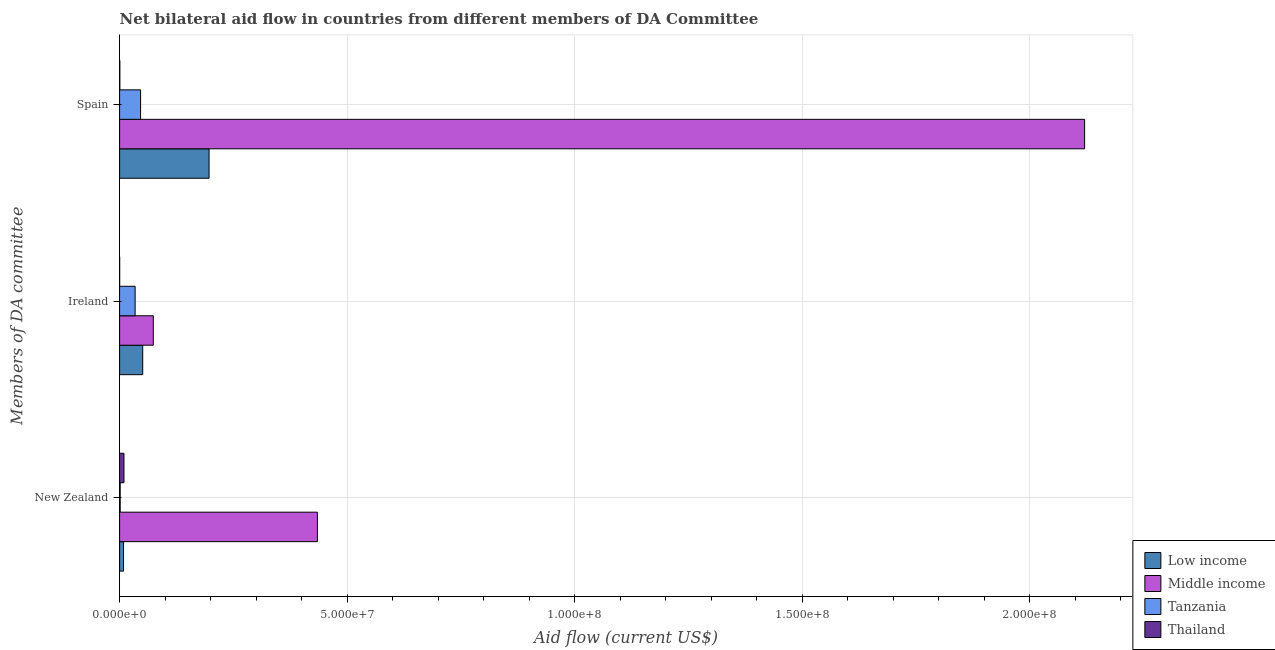How many different coloured bars are there?
Make the answer very short. 4. Are the number of bars per tick equal to the number of legend labels?
Your response must be concise. Yes. Are the number of bars on each tick of the Y-axis equal?
Your answer should be compact. Yes. How many bars are there on the 1st tick from the bottom?
Your response must be concise. 4. What is the label of the 2nd group of bars from the top?
Your response must be concise. Ireland. What is the amount of aid provided by spain in Low income?
Offer a terse response. 1.97e+07. Across all countries, what is the maximum amount of aid provided by ireland?
Keep it short and to the point. 7.41e+06. Across all countries, what is the minimum amount of aid provided by new zealand?
Keep it short and to the point. 1.30e+05. In which country was the amount of aid provided by new zealand minimum?
Keep it short and to the point. Tanzania. What is the total amount of aid provided by ireland in the graph?
Make the answer very short. 1.59e+07. What is the difference between the amount of aid provided by spain in Tanzania and that in Low income?
Offer a terse response. -1.50e+07. What is the difference between the amount of aid provided by ireland in Middle income and the amount of aid provided by new zealand in Tanzania?
Keep it short and to the point. 7.28e+06. What is the average amount of aid provided by new zealand per country?
Provide a short and direct response. 1.14e+07. What is the difference between the amount of aid provided by ireland and amount of aid provided by spain in Low income?
Provide a short and direct response. -1.46e+07. What is the ratio of the amount of aid provided by new zealand in Thailand to that in Tanzania?
Make the answer very short. 7.38. Is the amount of aid provided by new zealand in Low income less than that in Thailand?
Give a very brief answer. Yes. What is the difference between the highest and the second highest amount of aid provided by spain?
Ensure brevity in your answer.  1.92e+08. What is the difference between the highest and the lowest amount of aid provided by spain?
Provide a short and direct response. 2.12e+08. In how many countries, is the amount of aid provided by new zealand greater than the average amount of aid provided by new zealand taken over all countries?
Provide a short and direct response. 1. What does the 1st bar from the top in Spain represents?
Provide a short and direct response. Thailand. What does the 1st bar from the bottom in Ireland represents?
Offer a terse response. Low income. Is it the case that in every country, the sum of the amount of aid provided by new zealand and amount of aid provided by ireland is greater than the amount of aid provided by spain?
Provide a succinct answer. No. How many bars are there?
Keep it short and to the point. 12. Are all the bars in the graph horizontal?
Your answer should be compact. Yes. What is the difference between two consecutive major ticks on the X-axis?
Offer a very short reply. 5.00e+07. Are the values on the major ticks of X-axis written in scientific E-notation?
Your response must be concise. Yes. Does the graph contain grids?
Keep it short and to the point. Yes. Where does the legend appear in the graph?
Make the answer very short. Bottom right. How are the legend labels stacked?
Your response must be concise. Vertical. What is the title of the graph?
Offer a terse response. Net bilateral aid flow in countries from different members of DA Committee. Does "Europe(all income levels)" appear as one of the legend labels in the graph?
Provide a short and direct response. No. What is the label or title of the X-axis?
Provide a succinct answer. Aid flow (current US$). What is the label or title of the Y-axis?
Provide a succinct answer. Members of DA committee. What is the Aid flow (current US$) of Low income in New Zealand?
Your answer should be very brief. 8.70e+05. What is the Aid flow (current US$) in Middle income in New Zealand?
Make the answer very short. 4.35e+07. What is the Aid flow (current US$) of Tanzania in New Zealand?
Offer a very short reply. 1.30e+05. What is the Aid flow (current US$) in Thailand in New Zealand?
Your answer should be compact. 9.60e+05. What is the Aid flow (current US$) in Low income in Ireland?
Provide a short and direct response. 5.08e+06. What is the Aid flow (current US$) of Middle income in Ireland?
Your answer should be very brief. 7.41e+06. What is the Aid flow (current US$) of Tanzania in Ireland?
Keep it short and to the point. 3.41e+06. What is the Aid flow (current US$) of Low income in Spain?
Give a very brief answer. 1.97e+07. What is the Aid flow (current US$) of Middle income in Spain?
Offer a very short reply. 2.12e+08. What is the Aid flow (current US$) in Tanzania in Spain?
Your response must be concise. 4.61e+06. What is the Aid flow (current US$) in Thailand in Spain?
Provide a short and direct response. 5.00e+04. Across all Members of DA committee, what is the maximum Aid flow (current US$) in Low income?
Ensure brevity in your answer.  1.97e+07. Across all Members of DA committee, what is the maximum Aid flow (current US$) of Middle income?
Your answer should be very brief. 2.12e+08. Across all Members of DA committee, what is the maximum Aid flow (current US$) in Tanzania?
Ensure brevity in your answer.  4.61e+06. Across all Members of DA committee, what is the maximum Aid flow (current US$) in Thailand?
Keep it short and to the point. 9.60e+05. Across all Members of DA committee, what is the minimum Aid flow (current US$) in Low income?
Offer a terse response. 8.70e+05. Across all Members of DA committee, what is the minimum Aid flow (current US$) in Middle income?
Offer a very short reply. 7.41e+06. Across all Members of DA committee, what is the minimum Aid flow (current US$) in Tanzania?
Ensure brevity in your answer.  1.30e+05. What is the total Aid flow (current US$) of Low income in the graph?
Provide a succinct answer. 2.56e+07. What is the total Aid flow (current US$) of Middle income in the graph?
Your answer should be very brief. 2.63e+08. What is the total Aid flow (current US$) in Tanzania in the graph?
Make the answer very short. 8.15e+06. What is the total Aid flow (current US$) of Thailand in the graph?
Provide a short and direct response. 1.02e+06. What is the difference between the Aid flow (current US$) in Low income in New Zealand and that in Ireland?
Your answer should be very brief. -4.21e+06. What is the difference between the Aid flow (current US$) in Middle income in New Zealand and that in Ireland?
Give a very brief answer. 3.61e+07. What is the difference between the Aid flow (current US$) of Tanzania in New Zealand and that in Ireland?
Provide a short and direct response. -3.28e+06. What is the difference between the Aid flow (current US$) of Thailand in New Zealand and that in Ireland?
Give a very brief answer. 9.50e+05. What is the difference between the Aid flow (current US$) of Low income in New Zealand and that in Spain?
Your response must be concise. -1.88e+07. What is the difference between the Aid flow (current US$) in Middle income in New Zealand and that in Spain?
Make the answer very short. -1.69e+08. What is the difference between the Aid flow (current US$) in Tanzania in New Zealand and that in Spain?
Provide a succinct answer. -4.48e+06. What is the difference between the Aid flow (current US$) of Thailand in New Zealand and that in Spain?
Provide a succinct answer. 9.10e+05. What is the difference between the Aid flow (current US$) in Low income in Ireland and that in Spain?
Ensure brevity in your answer.  -1.46e+07. What is the difference between the Aid flow (current US$) in Middle income in Ireland and that in Spain?
Keep it short and to the point. -2.05e+08. What is the difference between the Aid flow (current US$) in Tanzania in Ireland and that in Spain?
Provide a succinct answer. -1.20e+06. What is the difference between the Aid flow (current US$) of Low income in New Zealand and the Aid flow (current US$) of Middle income in Ireland?
Offer a terse response. -6.54e+06. What is the difference between the Aid flow (current US$) of Low income in New Zealand and the Aid flow (current US$) of Tanzania in Ireland?
Give a very brief answer. -2.54e+06. What is the difference between the Aid flow (current US$) in Low income in New Zealand and the Aid flow (current US$) in Thailand in Ireland?
Ensure brevity in your answer.  8.60e+05. What is the difference between the Aid flow (current US$) of Middle income in New Zealand and the Aid flow (current US$) of Tanzania in Ireland?
Offer a terse response. 4.01e+07. What is the difference between the Aid flow (current US$) of Middle income in New Zealand and the Aid flow (current US$) of Thailand in Ireland?
Your response must be concise. 4.35e+07. What is the difference between the Aid flow (current US$) in Tanzania in New Zealand and the Aid flow (current US$) in Thailand in Ireland?
Offer a very short reply. 1.20e+05. What is the difference between the Aid flow (current US$) of Low income in New Zealand and the Aid flow (current US$) of Middle income in Spain?
Your answer should be very brief. -2.11e+08. What is the difference between the Aid flow (current US$) in Low income in New Zealand and the Aid flow (current US$) in Tanzania in Spain?
Ensure brevity in your answer.  -3.74e+06. What is the difference between the Aid flow (current US$) of Low income in New Zealand and the Aid flow (current US$) of Thailand in Spain?
Your answer should be very brief. 8.20e+05. What is the difference between the Aid flow (current US$) in Middle income in New Zealand and the Aid flow (current US$) in Tanzania in Spain?
Provide a short and direct response. 3.89e+07. What is the difference between the Aid flow (current US$) in Middle income in New Zealand and the Aid flow (current US$) in Thailand in Spain?
Give a very brief answer. 4.34e+07. What is the difference between the Aid flow (current US$) in Tanzania in New Zealand and the Aid flow (current US$) in Thailand in Spain?
Offer a terse response. 8.00e+04. What is the difference between the Aid flow (current US$) in Low income in Ireland and the Aid flow (current US$) in Middle income in Spain?
Your answer should be very brief. -2.07e+08. What is the difference between the Aid flow (current US$) of Low income in Ireland and the Aid flow (current US$) of Tanzania in Spain?
Offer a terse response. 4.70e+05. What is the difference between the Aid flow (current US$) in Low income in Ireland and the Aid flow (current US$) in Thailand in Spain?
Offer a very short reply. 5.03e+06. What is the difference between the Aid flow (current US$) of Middle income in Ireland and the Aid flow (current US$) of Tanzania in Spain?
Give a very brief answer. 2.80e+06. What is the difference between the Aid flow (current US$) in Middle income in Ireland and the Aid flow (current US$) in Thailand in Spain?
Your response must be concise. 7.36e+06. What is the difference between the Aid flow (current US$) of Tanzania in Ireland and the Aid flow (current US$) of Thailand in Spain?
Your response must be concise. 3.36e+06. What is the average Aid flow (current US$) in Low income per Members of DA committee?
Provide a short and direct response. 8.54e+06. What is the average Aid flow (current US$) of Middle income per Members of DA committee?
Provide a succinct answer. 8.77e+07. What is the average Aid flow (current US$) of Tanzania per Members of DA committee?
Provide a succinct answer. 2.72e+06. What is the difference between the Aid flow (current US$) of Low income and Aid flow (current US$) of Middle income in New Zealand?
Your answer should be compact. -4.26e+07. What is the difference between the Aid flow (current US$) of Low income and Aid flow (current US$) of Tanzania in New Zealand?
Keep it short and to the point. 7.40e+05. What is the difference between the Aid flow (current US$) of Low income and Aid flow (current US$) of Thailand in New Zealand?
Offer a terse response. -9.00e+04. What is the difference between the Aid flow (current US$) in Middle income and Aid flow (current US$) in Tanzania in New Zealand?
Your answer should be very brief. 4.33e+07. What is the difference between the Aid flow (current US$) of Middle income and Aid flow (current US$) of Thailand in New Zealand?
Offer a very short reply. 4.25e+07. What is the difference between the Aid flow (current US$) in Tanzania and Aid flow (current US$) in Thailand in New Zealand?
Ensure brevity in your answer.  -8.30e+05. What is the difference between the Aid flow (current US$) of Low income and Aid flow (current US$) of Middle income in Ireland?
Your answer should be compact. -2.33e+06. What is the difference between the Aid flow (current US$) in Low income and Aid flow (current US$) in Tanzania in Ireland?
Offer a very short reply. 1.67e+06. What is the difference between the Aid flow (current US$) of Low income and Aid flow (current US$) of Thailand in Ireland?
Your answer should be compact. 5.07e+06. What is the difference between the Aid flow (current US$) of Middle income and Aid flow (current US$) of Thailand in Ireland?
Your response must be concise. 7.40e+06. What is the difference between the Aid flow (current US$) in Tanzania and Aid flow (current US$) in Thailand in Ireland?
Keep it short and to the point. 3.40e+06. What is the difference between the Aid flow (current US$) of Low income and Aid flow (current US$) of Middle income in Spain?
Provide a short and direct response. -1.92e+08. What is the difference between the Aid flow (current US$) in Low income and Aid flow (current US$) in Tanzania in Spain?
Make the answer very short. 1.50e+07. What is the difference between the Aid flow (current US$) in Low income and Aid flow (current US$) in Thailand in Spain?
Keep it short and to the point. 1.96e+07. What is the difference between the Aid flow (current US$) in Middle income and Aid flow (current US$) in Tanzania in Spain?
Provide a short and direct response. 2.07e+08. What is the difference between the Aid flow (current US$) in Middle income and Aid flow (current US$) in Thailand in Spain?
Your answer should be very brief. 2.12e+08. What is the difference between the Aid flow (current US$) in Tanzania and Aid flow (current US$) in Thailand in Spain?
Make the answer very short. 4.56e+06. What is the ratio of the Aid flow (current US$) in Low income in New Zealand to that in Ireland?
Your answer should be very brief. 0.17. What is the ratio of the Aid flow (current US$) in Middle income in New Zealand to that in Ireland?
Offer a very short reply. 5.87. What is the ratio of the Aid flow (current US$) in Tanzania in New Zealand to that in Ireland?
Offer a terse response. 0.04. What is the ratio of the Aid flow (current US$) of Thailand in New Zealand to that in Ireland?
Keep it short and to the point. 96. What is the ratio of the Aid flow (current US$) of Low income in New Zealand to that in Spain?
Make the answer very short. 0.04. What is the ratio of the Aid flow (current US$) in Middle income in New Zealand to that in Spain?
Offer a very short reply. 0.2. What is the ratio of the Aid flow (current US$) in Tanzania in New Zealand to that in Spain?
Provide a succinct answer. 0.03. What is the ratio of the Aid flow (current US$) in Low income in Ireland to that in Spain?
Ensure brevity in your answer.  0.26. What is the ratio of the Aid flow (current US$) of Middle income in Ireland to that in Spain?
Give a very brief answer. 0.03. What is the ratio of the Aid flow (current US$) of Tanzania in Ireland to that in Spain?
Provide a short and direct response. 0.74. What is the ratio of the Aid flow (current US$) of Thailand in Ireland to that in Spain?
Make the answer very short. 0.2. What is the difference between the highest and the second highest Aid flow (current US$) in Low income?
Ensure brevity in your answer.  1.46e+07. What is the difference between the highest and the second highest Aid flow (current US$) in Middle income?
Give a very brief answer. 1.69e+08. What is the difference between the highest and the second highest Aid flow (current US$) in Tanzania?
Your response must be concise. 1.20e+06. What is the difference between the highest and the second highest Aid flow (current US$) in Thailand?
Provide a short and direct response. 9.10e+05. What is the difference between the highest and the lowest Aid flow (current US$) in Low income?
Keep it short and to the point. 1.88e+07. What is the difference between the highest and the lowest Aid flow (current US$) of Middle income?
Keep it short and to the point. 2.05e+08. What is the difference between the highest and the lowest Aid flow (current US$) of Tanzania?
Provide a succinct answer. 4.48e+06. What is the difference between the highest and the lowest Aid flow (current US$) of Thailand?
Your response must be concise. 9.50e+05. 